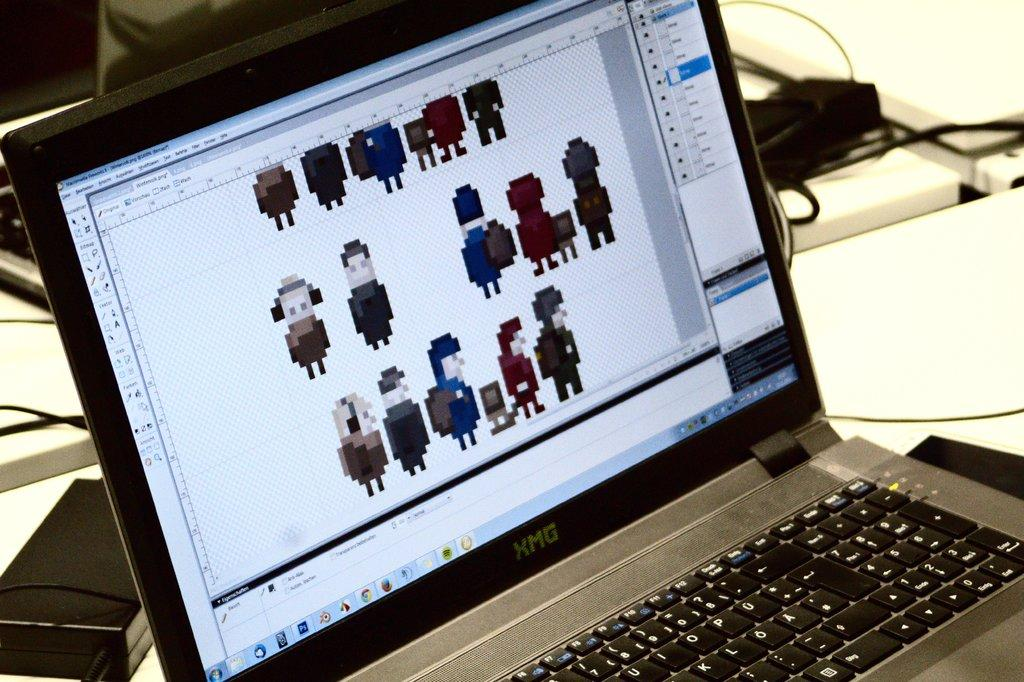<image>
Offer a succinct explanation of the picture presented. An XMG laptop is showing a screen of some animated people. 